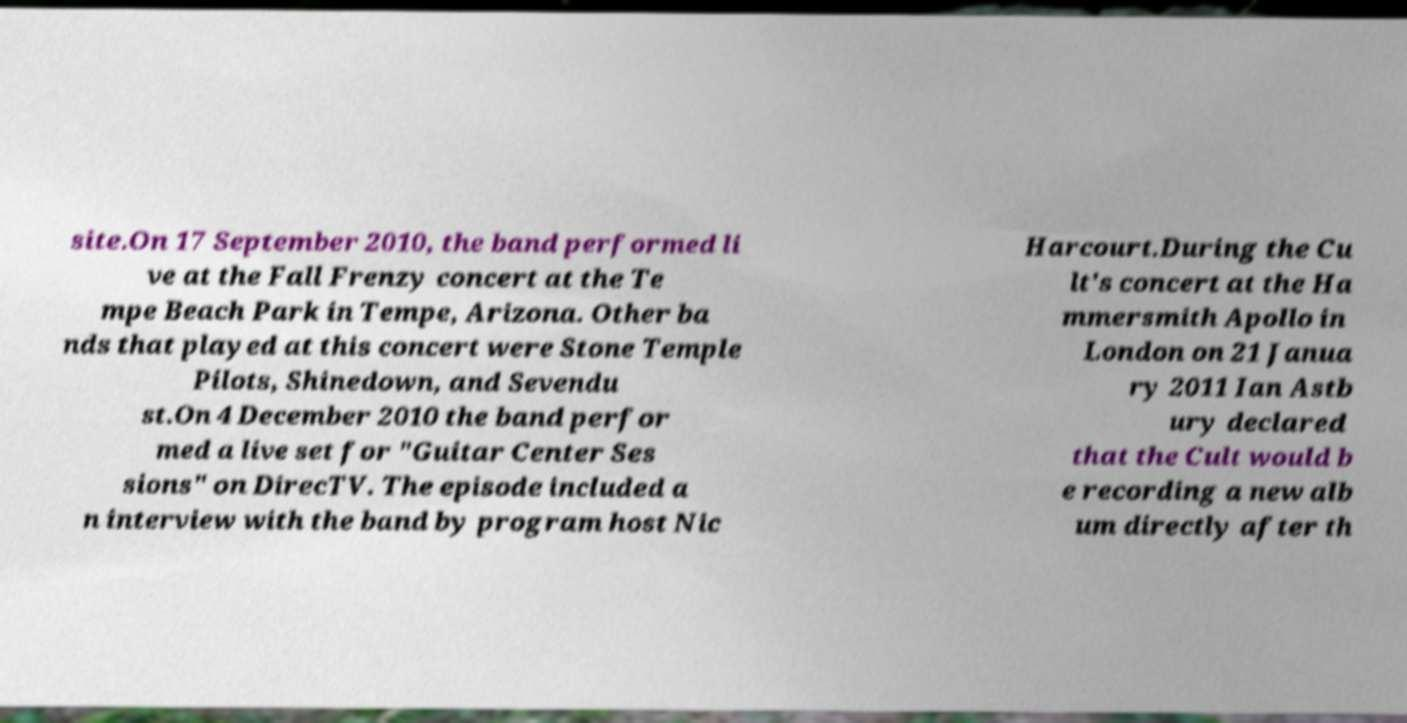For documentation purposes, I need the text within this image transcribed. Could you provide that? site.On 17 September 2010, the band performed li ve at the Fall Frenzy concert at the Te mpe Beach Park in Tempe, Arizona. Other ba nds that played at this concert were Stone Temple Pilots, Shinedown, and Sevendu st.On 4 December 2010 the band perfor med a live set for "Guitar Center Ses sions" on DirecTV. The episode included a n interview with the band by program host Nic Harcourt.During the Cu lt's concert at the Ha mmersmith Apollo in London on 21 Janua ry 2011 Ian Astb ury declared that the Cult would b e recording a new alb um directly after th 